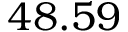Convert formula to latex. <formula><loc_0><loc_0><loc_500><loc_500>4 8 . 5 9</formula> 